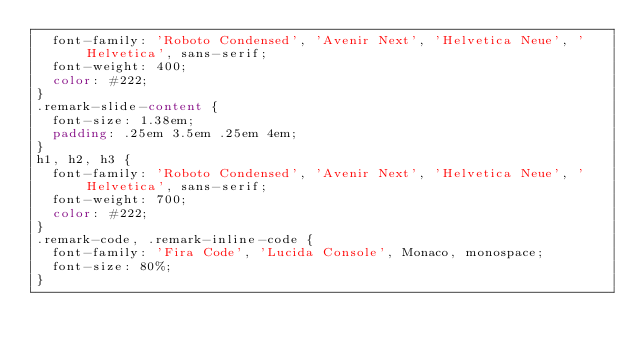<code> <loc_0><loc_0><loc_500><loc_500><_CSS_>  font-family: 'Roboto Condensed', 'Avenir Next', 'Helvetica Neue', 'Helvetica', sans-serif;
  font-weight: 400;
  color: #222;
}
.remark-slide-content {
  font-size: 1.38em;
  padding: .25em 3.5em .25em 4em;
}
h1, h2, h3 {
  font-family: 'Roboto Condensed', 'Avenir Next', 'Helvetica Neue', 'Helvetica', sans-serif;
  font-weight: 700;
  color: #222;
}
.remark-code, .remark-inline-code {
  font-family: 'Fira Code', 'Lucida Console', Monaco, monospace;
  font-size: 80%;
}</code> 